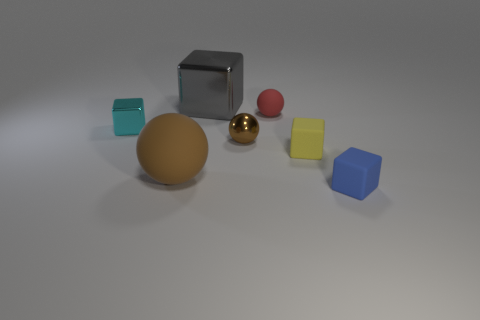Are any blue metal balls visible?
Give a very brief answer. No. What material is the tiny thing that is the same color as the big sphere?
Ensure brevity in your answer.  Metal. What is the size of the matte sphere behind the large thing that is in front of the small metal object on the left side of the gray object?
Your answer should be compact. Small. There is a small yellow thing; does it have the same shape as the brown thing on the left side of the gray cube?
Your answer should be very brief. No. Is there a large object of the same color as the metal sphere?
Your answer should be very brief. Yes. What number of spheres are large objects or brown metallic objects?
Ensure brevity in your answer.  2. Are there any tiny red things of the same shape as the large shiny object?
Keep it short and to the point. No. How many other things are the same color as the large rubber ball?
Your response must be concise. 1. Are there fewer red things that are on the left side of the big brown ball than red spheres?
Your response must be concise. Yes. What number of large yellow balls are there?
Your answer should be very brief. 0. 